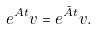Convert formula to latex. <formula><loc_0><loc_0><loc_500><loc_500>e ^ { A t } v = e ^ { \tilde { A } t } v .</formula> 